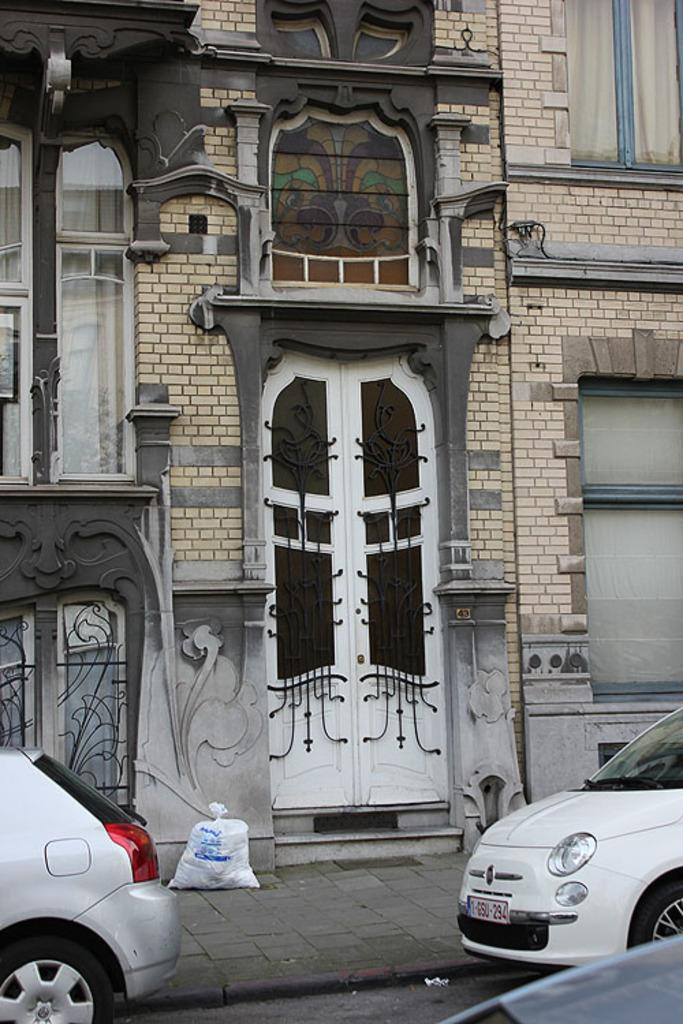What can be seen on both sides of the image? There are cars on either side of the image. What else is present in the image besides the cars? There is a message and a building in the image. Can you describe the building in the image? The building in the image is in the middle, has windows, and doors. What type of berry is being used to create the message in the image? There is no berry present in the image, and the message is not created using berries. Can you describe the elbow of the person holding the yarn in the image? There is no person holding yarn in the image, and therefore no elbow to describe. 